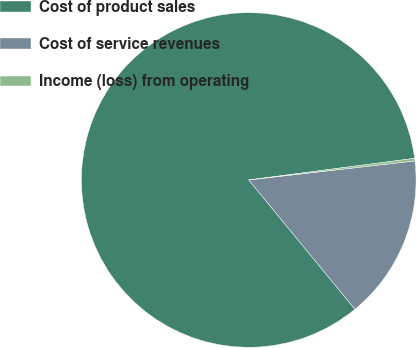Convert chart to OTSL. <chart><loc_0><loc_0><loc_500><loc_500><pie_chart><fcel>Cost of product sales<fcel>Cost of service revenues<fcel>Income (loss) from operating<nl><fcel>83.88%<fcel>15.87%<fcel>0.25%<nl></chart> 